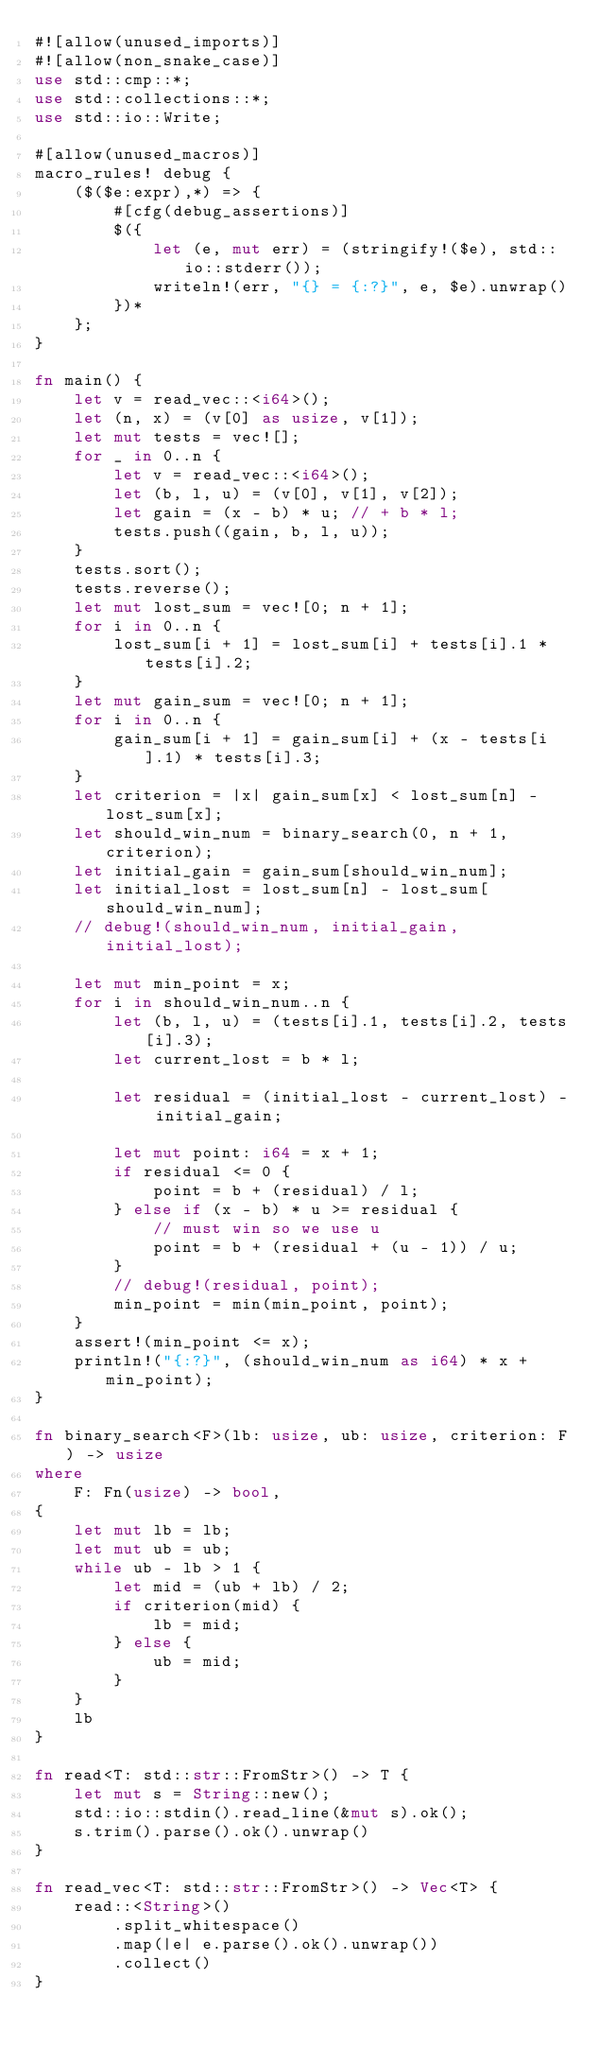<code> <loc_0><loc_0><loc_500><loc_500><_Rust_>#![allow(unused_imports)]
#![allow(non_snake_case)]
use std::cmp::*;
use std::collections::*;
use std::io::Write;

#[allow(unused_macros)]
macro_rules! debug {
    ($($e:expr),*) => {
        #[cfg(debug_assertions)]
        $({
            let (e, mut err) = (stringify!($e), std::io::stderr());
            writeln!(err, "{} = {:?}", e, $e).unwrap()
        })*
    };
}

fn main() {
    let v = read_vec::<i64>();
    let (n, x) = (v[0] as usize, v[1]);
    let mut tests = vec![];
    for _ in 0..n {
        let v = read_vec::<i64>();
        let (b, l, u) = (v[0], v[1], v[2]);
        let gain = (x - b) * u; // + b * l;
        tests.push((gain, b, l, u));
    }
    tests.sort();
    tests.reverse();
    let mut lost_sum = vec![0; n + 1];
    for i in 0..n {
        lost_sum[i + 1] = lost_sum[i] + tests[i].1 * tests[i].2;
    }
    let mut gain_sum = vec![0; n + 1];
    for i in 0..n {
        gain_sum[i + 1] = gain_sum[i] + (x - tests[i].1) * tests[i].3;
    }
    let criterion = |x| gain_sum[x] < lost_sum[n] - lost_sum[x];
    let should_win_num = binary_search(0, n + 1, criterion);
    let initial_gain = gain_sum[should_win_num];
    let initial_lost = lost_sum[n] - lost_sum[should_win_num];
    // debug!(should_win_num, initial_gain, initial_lost);

    let mut min_point = x;
    for i in should_win_num..n {
        let (b, l, u) = (tests[i].1, tests[i].2, tests[i].3);
        let current_lost = b * l;

        let residual = (initial_lost - current_lost) - initial_gain;

        let mut point: i64 = x + 1;
        if residual <= 0 {
            point = b + (residual) / l;
        } else if (x - b) * u >= residual {
            // must win so we use u
            point = b + (residual + (u - 1)) / u;
        }
        // debug!(residual, point);
        min_point = min(min_point, point);
    }
    assert!(min_point <= x);
    println!("{:?}", (should_win_num as i64) * x + min_point);
}

fn binary_search<F>(lb: usize, ub: usize, criterion: F) -> usize
where
    F: Fn(usize) -> bool,
{
    let mut lb = lb;
    let mut ub = ub;
    while ub - lb > 1 {
        let mid = (ub + lb) / 2;
        if criterion(mid) {
            lb = mid;
        } else {
            ub = mid;
        }
    }
    lb
}

fn read<T: std::str::FromStr>() -> T {
    let mut s = String::new();
    std::io::stdin().read_line(&mut s).ok();
    s.trim().parse().ok().unwrap()
}

fn read_vec<T: std::str::FromStr>() -> Vec<T> {
    read::<String>()
        .split_whitespace()
        .map(|e| e.parse().ok().unwrap())
        .collect()
}
</code> 